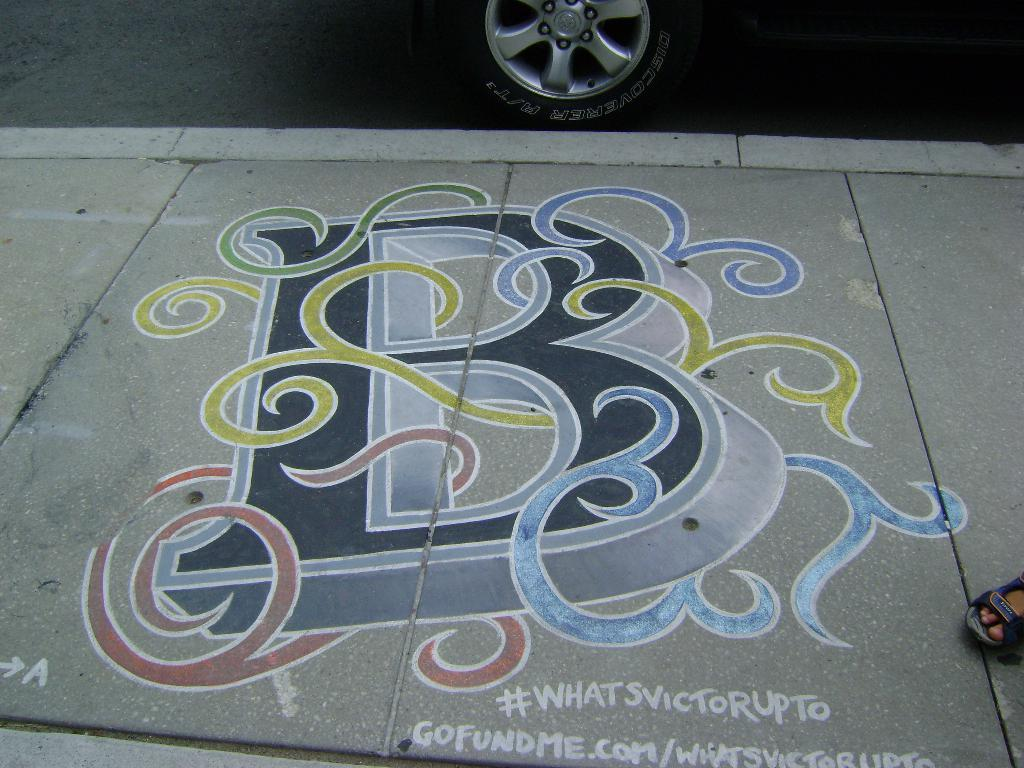What is the medium of the artwork in the image? The image is a painting on the footpath. What is the main subject of the painting? There is a wheel depicted in the painting. Can you describe any other elements in the image? A person's foot with footwear is visible in the right corner of the image. What type of tray is being used to carry the invention in the image? There is no tray or invention present in the image; it features a painting of a wheel and a person's foot. Can you describe the wound on the person's foot in the image? There is no wound visible on the person's foot in the image. 